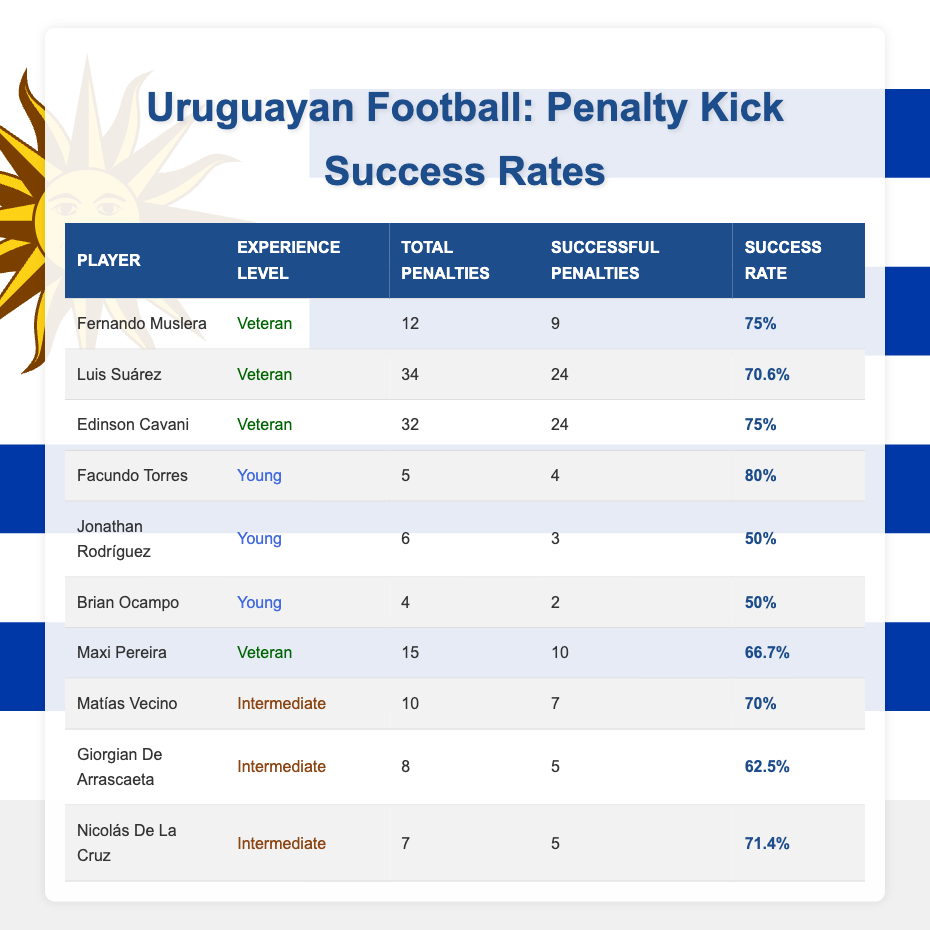What is the success rate of Edinson Cavani? Edinson Cavani's success rate is provided directly in the table, where it shows he has a success rate of 75%.
Answer: 75% Which player has the highest success rate among young players? Looking at the success rates for young players: Facundo Torres has a success rate of 80%, while Jonathan Rodríguez and Brian Ocampo both have rates of 50%. Therefore, Facundo Torres has the highest success rate among young players.
Answer: Facundo Torres How many successful penalties did Fernando Muslera convert? In the table, it states that Fernando Muslera successfully converted 9 penalties out of a total of 12 attempts, which can be found directly in the relevant row.
Answer: 9 What is the average success rate of the veteran players? The success rates for veteran players are: Fernando Muslera (75%), Luis Suárez (70.6%), Edinson Cavani (75%), and Maxi Pereira (66.7%). To find the average, we sum the success rates (75 + 70.6 + 75 + 66.7) = 287.3 and then divide by the number of veteran players (4). So, the average is 287.3/4 = 71.825.
Answer: 71.83 (rounded) Is it true that Jonathan Rodríguez has a better success rate than Brian Ocampo? Jonathan Rodríguez has a success rate of 50%, while Brian Ocampo also has a success rate of 50%. Since both values are equal, the statement is false.
Answer: No How many total penalties were taken by players with an experience level of intermediate? The total penalties for intermediate players are Matías Vecino (10), Giorgian De Arrascaeta (8), and Nicolás De La Cruz (7). Adding these gives us a total of (10 + 8 + 7) = 25 penalties.
Answer: 25 Who has the lowest success rate among all the players? The success rates in the table show that Jonathan Rodríguez and Brian Ocampo both have the lowest success rate at 50%. They both have the same rate, but since we are asked for one, we can cite Jonathan Rodríguez as an example.
Answer: Jonathan Rodríguez What is the difference in total penalties taken between the player with the most total penalties and the player with the least total penalties? The player with the most total penalties is Luis Suárez with 34 penalties, and the player with the least is Brian Ocampo with 4 penalties. The difference is calculated as (34 - 4) = 30.
Answer: 30 